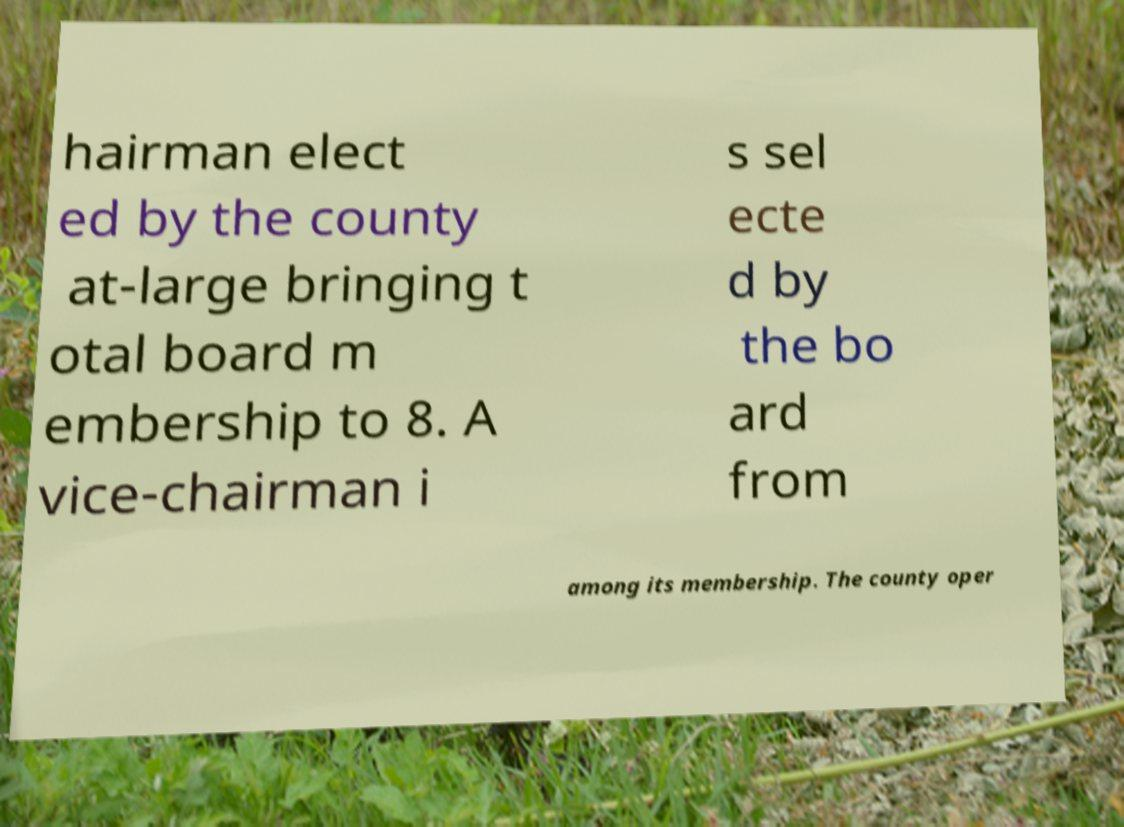Please identify and transcribe the text found in this image. hairman elect ed by the county at-large bringing t otal board m embership to 8. A vice-chairman i s sel ecte d by the bo ard from among its membership. The county oper 